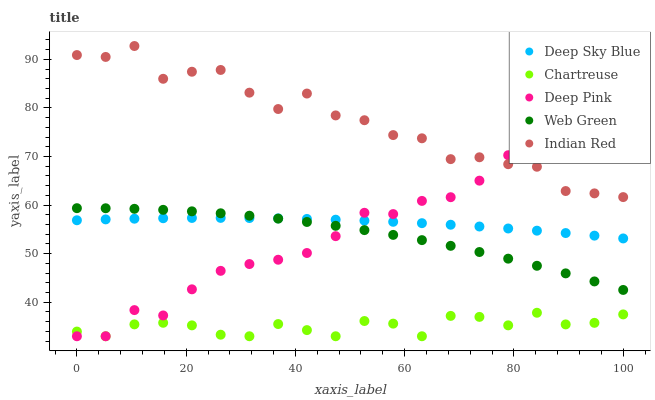Does Chartreuse have the minimum area under the curve?
Answer yes or no. Yes. Does Indian Red have the maximum area under the curve?
Answer yes or no. Yes. Does Deep Pink have the minimum area under the curve?
Answer yes or no. No. Does Deep Pink have the maximum area under the curve?
Answer yes or no. No. Is Deep Sky Blue the smoothest?
Answer yes or no. Yes. Is Indian Red the roughest?
Answer yes or no. Yes. Is Chartreuse the smoothest?
Answer yes or no. No. Is Chartreuse the roughest?
Answer yes or no. No. Does Chartreuse have the lowest value?
Answer yes or no. Yes. Does Web Green have the lowest value?
Answer yes or no. No. Does Indian Red have the highest value?
Answer yes or no. Yes. Does Deep Pink have the highest value?
Answer yes or no. No. Is Chartreuse less than Web Green?
Answer yes or no. Yes. Is Web Green greater than Chartreuse?
Answer yes or no. Yes. Does Indian Red intersect Deep Pink?
Answer yes or no. Yes. Is Indian Red less than Deep Pink?
Answer yes or no. No. Is Indian Red greater than Deep Pink?
Answer yes or no. No. Does Chartreuse intersect Web Green?
Answer yes or no. No. 